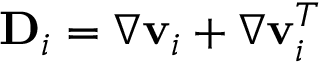Convert formula to latex. <formula><loc_0><loc_0><loc_500><loc_500>{ D } _ { i } = \nabla { v } _ { i } + \nabla { v } _ { i } ^ { T }</formula> 